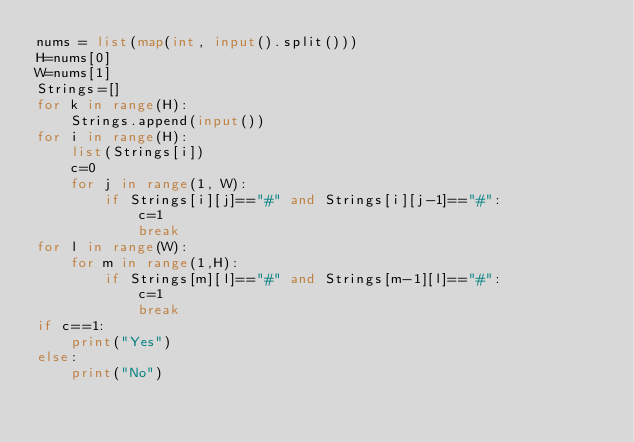Convert code to text. <code><loc_0><loc_0><loc_500><loc_500><_Python_>nums = list(map(int, input().split()))
H=nums[0]
W=nums[1]
Strings=[]
for k in range(H):
    Strings.append(input())
for i in range(H):
    list(Strings[i])
    c=0
    for j in range(1, W):
        if Strings[i][j]=="#" and Strings[i][j-1]=="#":
            c=1
            break
for l in range(W):
    for m in range(1,H):
        if Strings[m][l]=="#" and Strings[m-1][l]=="#":
            c=1
            break
if c==1:
    print("Yes") 
else:
    print("No")</code> 